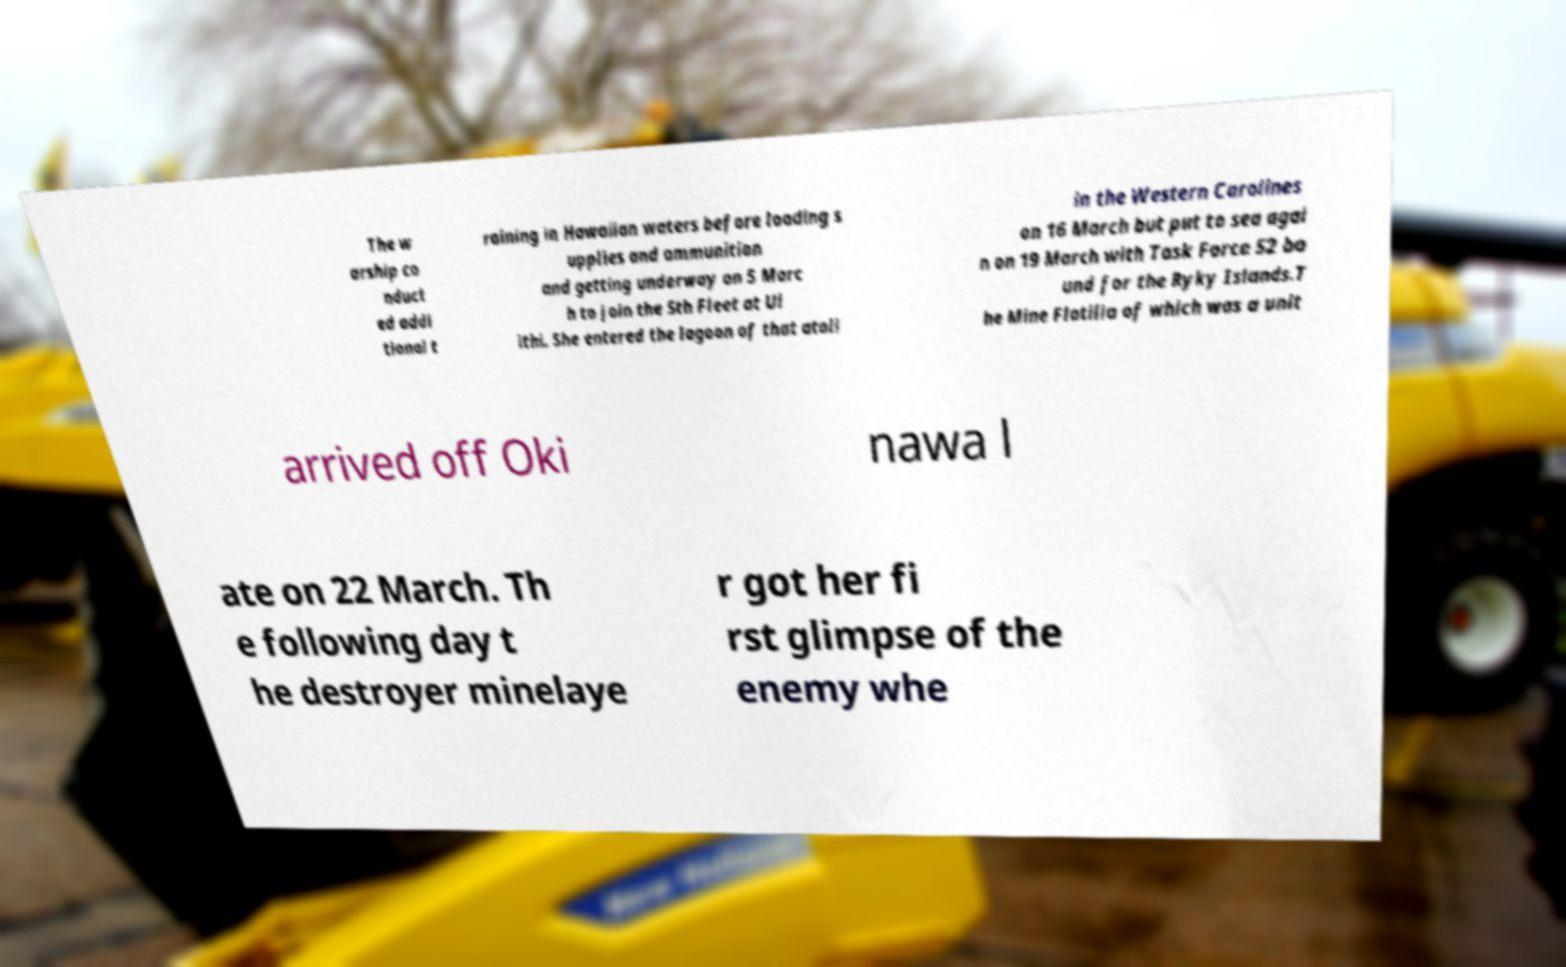I need the written content from this picture converted into text. Can you do that? The w arship co nduct ed addi tional t raining in Hawaiian waters before loading s upplies and ammunition and getting underway on 5 Marc h to join the 5th Fleet at Ul ithi. She entered the lagoon of that atoll in the Western Carolines on 16 March but put to sea agai n on 19 March with Task Force 52 bo und for the Ryky Islands.T he Mine Flotilla of which was a unit arrived off Oki nawa l ate on 22 March. Th e following day t he destroyer minelaye r got her fi rst glimpse of the enemy whe 